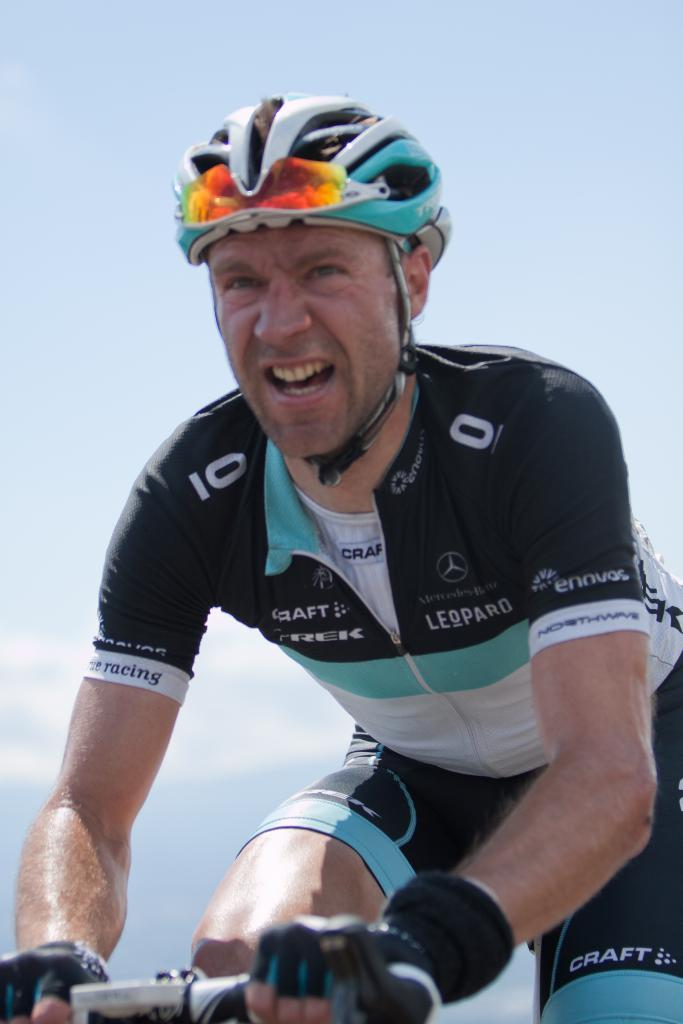What is the main subject of the image? The main subject of the image is a man. What is the man doing in the image? The man is riding a bicycle in the image. What safety precaution is the man taking while riding the bicycle? The man is wearing a helmet in the image. What flavor of ice cream is the man holding while riding the bicycle? There is no ice cream present in the image, and the man is not holding any. 